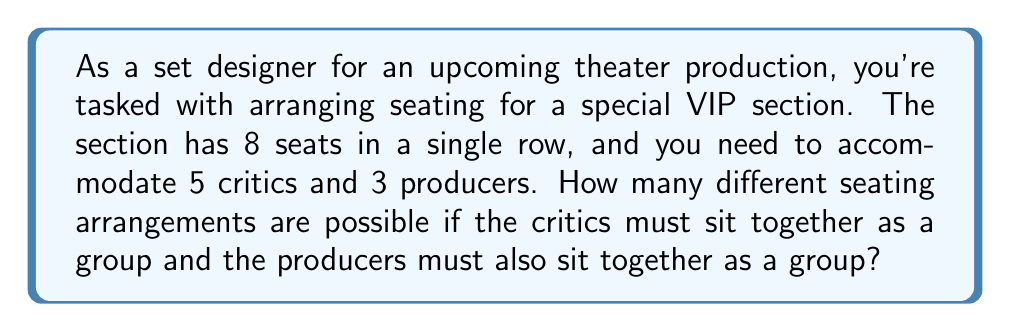Provide a solution to this math problem. Let's approach this problem step-by-step using combinatorial set theory:

1) First, we can consider the critics and producers as two distinct units. So, we essentially have 2 objects to arrange in a row.

2) The number of ways to arrange 2 objects is simply 2! = 2.

3) Now, within each group, we need to consider the arrangements:
   
   a) For the critics: There are 5 critics, so there are 5! ways to arrange them.
   
   b) For the producers: There are 3 producers, so there are 3! ways to arrange them.

4) By the multiplication principle, the total number of arrangements is:

   $$ 2! \times 5! \times 3! $$

5) Let's calculate this:
   $$ 2 \times 120 \times 6 = 1,440 $$

Therefore, there are 1,440 possible seating arrangements that satisfy the given conditions.

This problem demonstrates the use of the multiplication principle in set theory and the concept of permutations, which are essential in combinatorial problems often encountered in theater seating arrangements.
Answer: 1,440 possible seating arrangements 